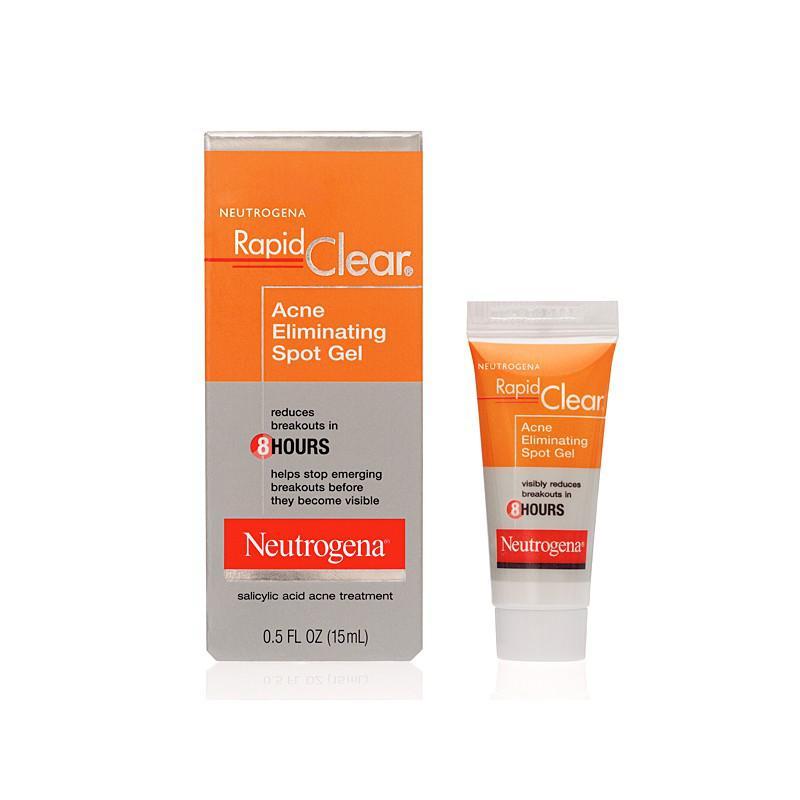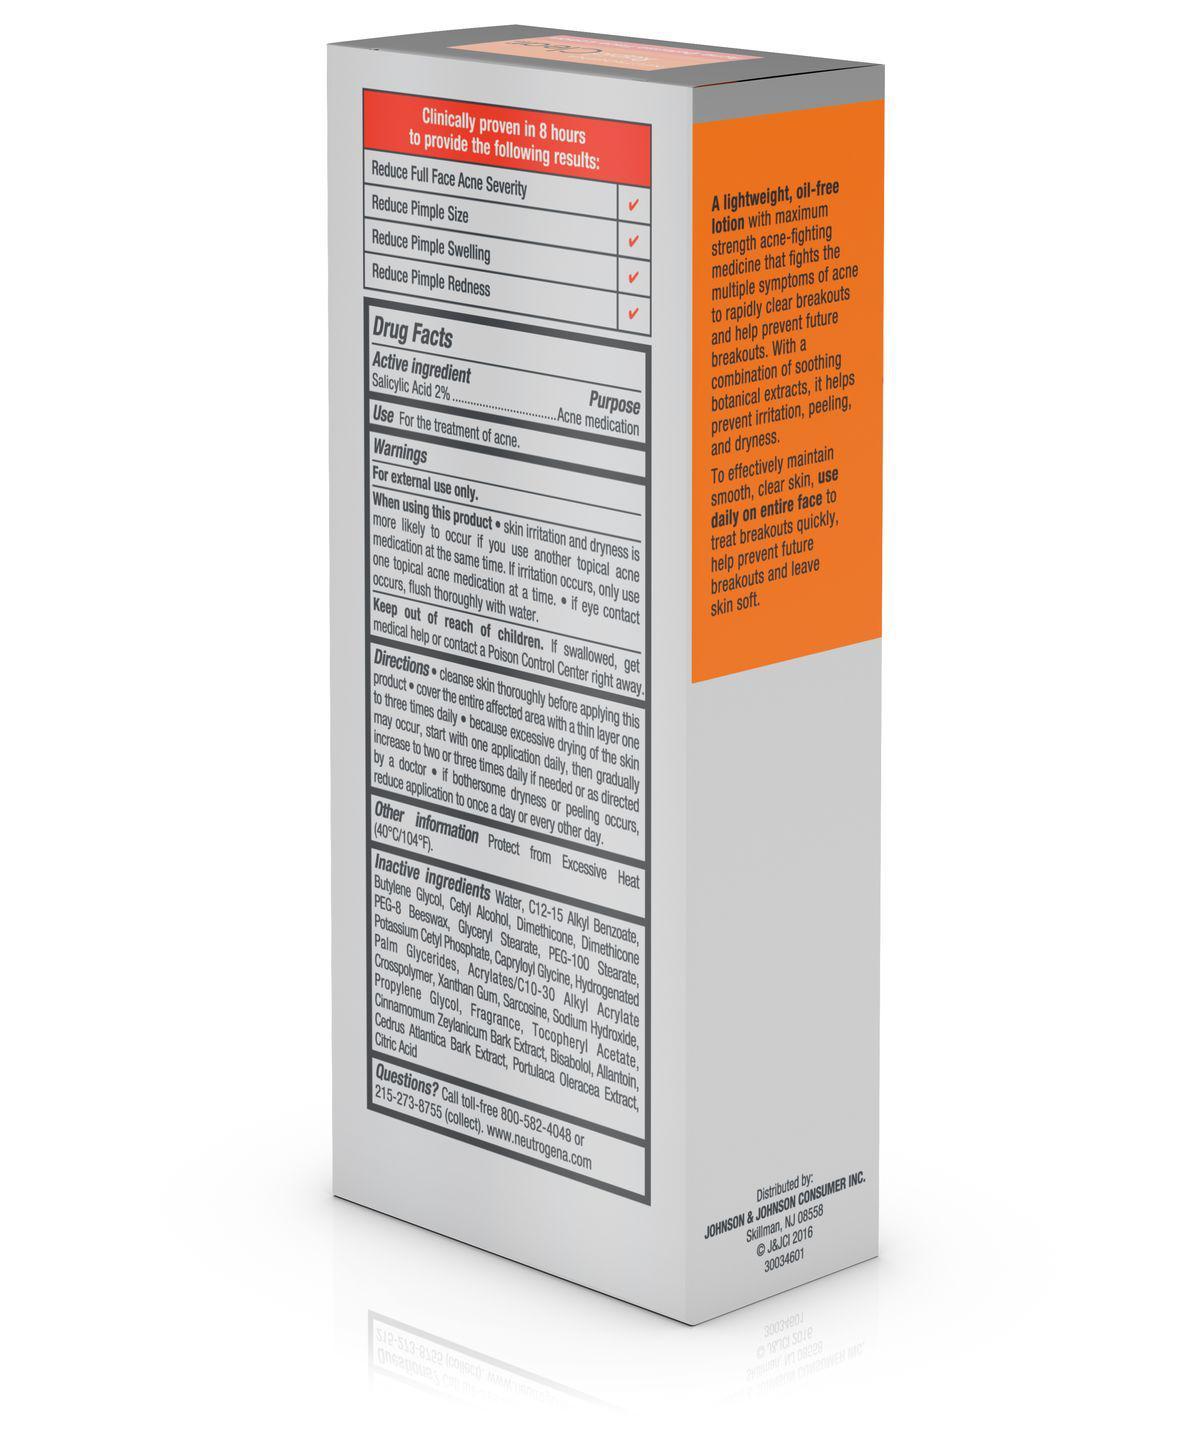The first image is the image on the left, the second image is the image on the right. Evaluate the accuracy of this statement regarding the images: "Left image shows a product with orange top half and light bottom half.". Is it true? Answer yes or no. Yes. The first image is the image on the left, the second image is the image on the right. Analyze the images presented: Is the assertion "In one image, a product in a tube stands on end beside the box in which it is packaged to be sold." valid? Answer yes or no. Yes. 